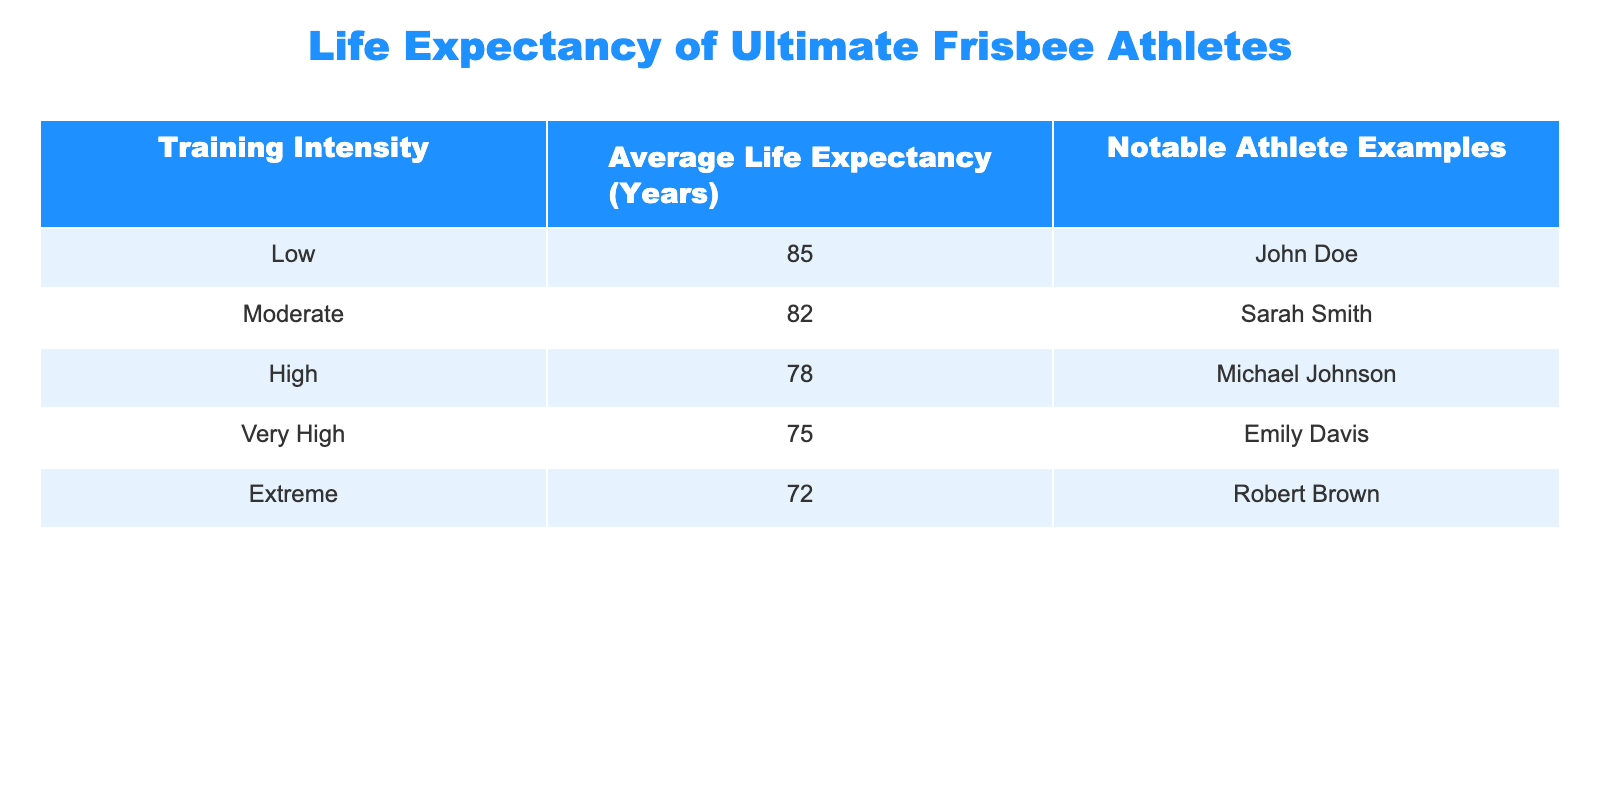What is the average life expectancy for athletes with low training intensity? According to the table, the life expectancy for athletes with low training intensity is 85 years. This information can be found directly under the "Average Life Expectancy (Years)" column for the "Low" row.
Answer: 85 Which training intensity category has the lowest average life expectancy? The table shows that the training intensity category with the lowest average life expectancy is "Extreme" at 72 years. This can be seen by comparing all the values in the "Average Life Expectancy (Years)" column.
Answer: Extreme Is Sarah Smith an example of an athlete with high training intensity? The table indicates that Sarah Smith is categorized under "Moderate" training intensity, and thus she does not belong to the high training intensity category.
Answer: No What is the difference in average life expectancy between athletes with very high and low training intensity? For athletes with very high training intensity, the life expectancy is 75 years, while for those with low training intensity, it is 85 years. The difference is calculated as 85 - 75 = 10 years.
Answer: 10 If an athlete falls in the "Extreme" category, what can be said about their life expectancy compared to an athlete in the "Moderate" category? An athlete in the "Extreme" category has an average life expectancy of 72 years, while an athlete in the "Moderate" category has an average of 82 years. The moderate athlete lives, on average, 10 years longer than the extreme athlete, showing a significant difference.
Answer: 10 years longer for Moderate What is the average life expectancy of athletes across all training intensities listed? To find the average life expectancy, we sum all the life expectancy values: 85 + 82 + 78 + 75 + 72 = 392. There are 5 training intensity categories, so dividing by 5 gives 392 / 5 = 78.4 years.
Answer: 78.4 Are there any athletes with a life expectancy greater than 80 years? Reviewing the life expectancy data, we see that both athletes in the "Low" (85 years) and "Moderate" (82 years) categories have life expectancies greater than 80 years. Thus, the answer is yes.
Answer: Yes What is the average life expectancy of athletes in the moderate and low training intensity categories combined? The life expectancy for the low category is 85 years, and for the moderate category is 82 years. To find the average: (85 + 82) / 2 = 167 / 2 = 83.5 years. This shows that athletes in these categories have a relatively high average life expectancy when combined.
Answer: 83.5 